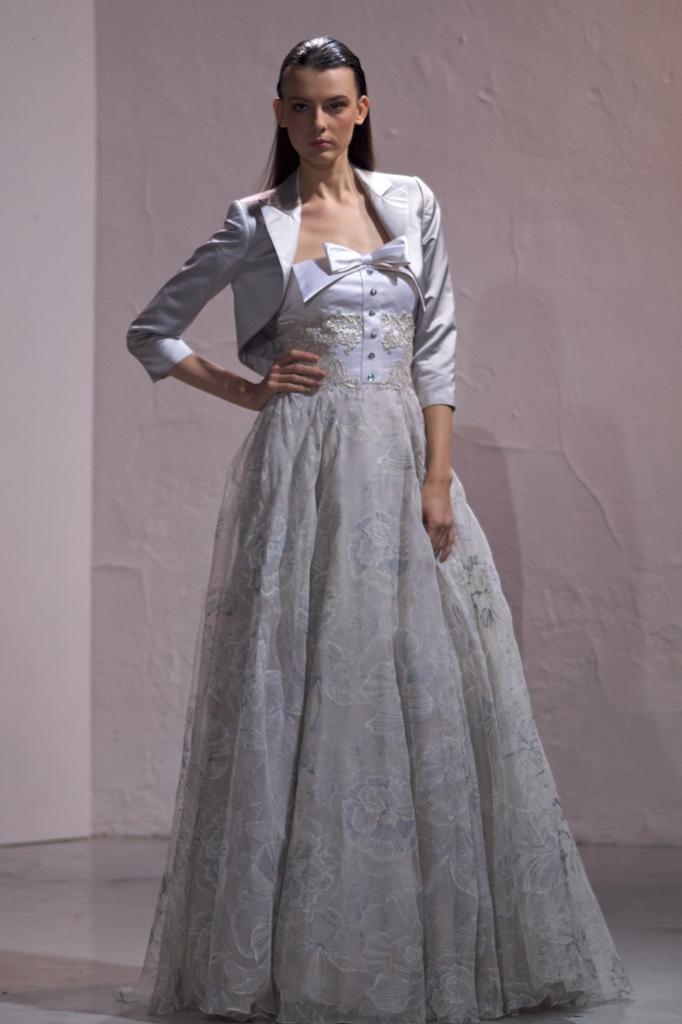Please provide a concise description of this image. In this image I can see the person standing and the person is wearing white color dress and I can see the white color background. 